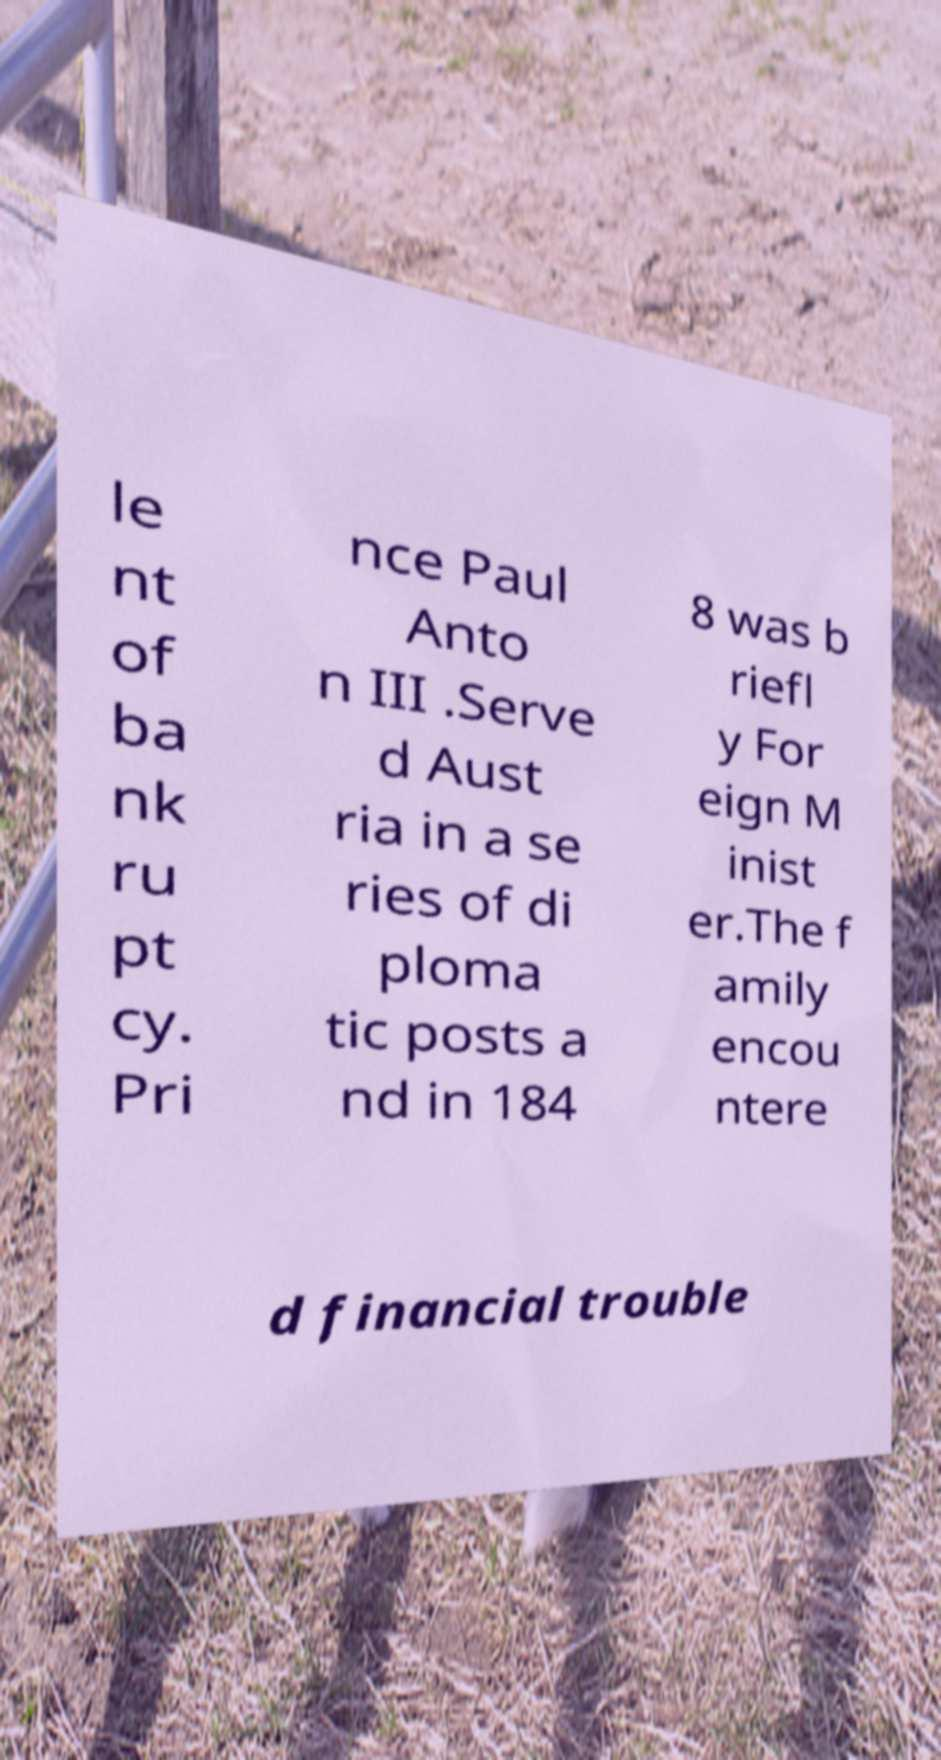Please read and relay the text visible in this image. What does it say? le nt of ba nk ru pt cy. Pri nce Paul Anto n III .Serve d Aust ria in a se ries of di ploma tic posts a nd in 184 8 was b riefl y For eign M inist er.The f amily encou ntere d financial trouble 